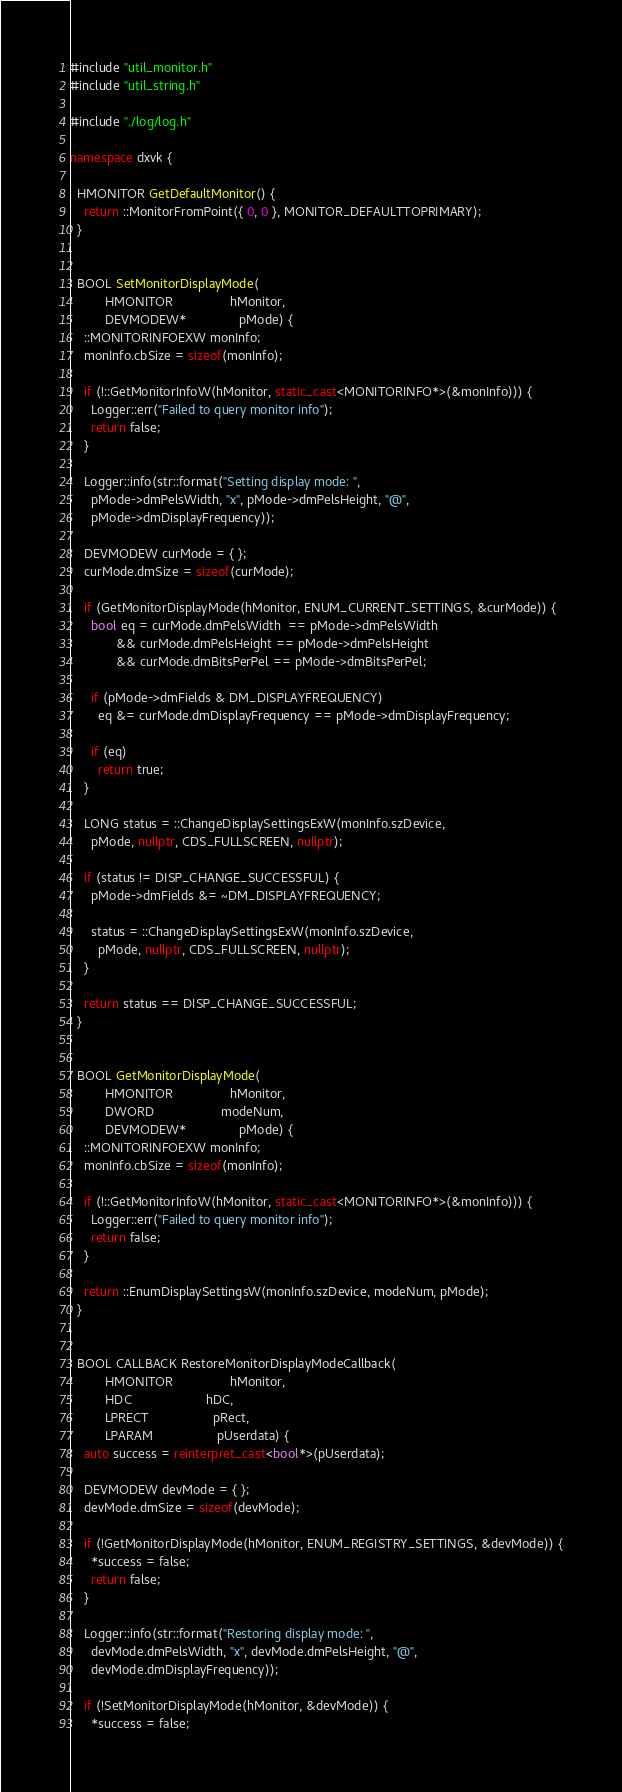Convert code to text. <code><loc_0><loc_0><loc_500><loc_500><_C++_>#include "util_monitor.h"
#include "util_string.h"

#include "./log/log.h"

namespace dxvk {
  
  HMONITOR GetDefaultMonitor() {
    return ::MonitorFromPoint({ 0, 0 }, MONITOR_DEFAULTTOPRIMARY);
  }


  BOOL SetMonitorDisplayMode(
          HMONITOR                hMonitor,
          DEVMODEW*               pMode) {
    ::MONITORINFOEXW monInfo;
    monInfo.cbSize = sizeof(monInfo);

    if (!::GetMonitorInfoW(hMonitor, static_cast<MONITORINFO*>(&monInfo))) {
      Logger::err("Failed to query monitor info");
      return false;
    }

    Logger::info(str::format("Setting display mode: ",
      pMode->dmPelsWidth, "x", pMode->dmPelsHeight, "@",
      pMode->dmDisplayFrequency));

    DEVMODEW curMode = { };
    curMode.dmSize = sizeof(curMode);

    if (GetMonitorDisplayMode(hMonitor, ENUM_CURRENT_SETTINGS, &curMode)) {
      bool eq = curMode.dmPelsWidth  == pMode->dmPelsWidth
             && curMode.dmPelsHeight == pMode->dmPelsHeight
             && curMode.dmBitsPerPel == pMode->dmBitsPerPel;

      if (pMode->dmFields & DM_DISPLAYFREQUENCY)
        eq &= curMode.dmDisplayFrequency == pMode->dmDisplayFrequency;

      if (eq)
        return true;
    }

    LONG status = ::ChangeDisplaySettingsExW(monInfo.szDevice,
      pMode, nullptr, CDS_FULLSCREEN, nullptr);

    if (status != DISP_CHANGE_SUCCESSFUL) {
      pMode->dmFields &= ~DM_DISPLAYFREQUENCY;

      status = ::ChangeDisplaySettingsExW(monInfo.szDevice,
        pMode, nullptr, CDS_FULLSCREEN, nullptr);
    }

    return status == DISP_CHANGE_SUCCESSFUL;
  }


  BOOL GetMonitorDisplayMode(
          HMONITOR                hMonitor,
          DWORD                   modeNum,
          DEVMODEW*               pMode) {
    ::MONITORINFOEXW monInfo;
    monInfo.cbSize = sizeof(monInfo);

    if (!::GetMonitorInfoW(hMonitor, static_cast<MONITORINFO*>(&monInfo))) {
      Logger::err("Failed to query monitor info");
      return false;
    }

    return ::EnumDisplaySettingsW(monInfo.szDevice, modeNum, pMode);
  }


  BOOL CALLBACK RestoreMonitorDisplayModeCallback(
          HMONITOR                hMonitor,
          HDC                     hDC,
          LPRECT                  pRect,
          LPARAM                  pUserdata) {
    auto success = reinterpret_cast<bool*>(pUserdata);

    DEVMODEW devMode = { };
    devMode.dmSize = sizeof(devMode);

    if (!GetMonitorDisplayMode(hMonitor, ENUM_REGISTRY_SETTINGS, &devMode)) {
      *success = false;
      return false;
    }

    Logger::info(str::format("Restoring display mode: ",
      devMode.dmPelsWidth, "x", devMode.dmPelsHeight, "@",
      devMode.dmDisplayFrequency));

    if (!SetMonitorDisplayMode(hMonitor, &devMode)) {
      *success = false;</code> 